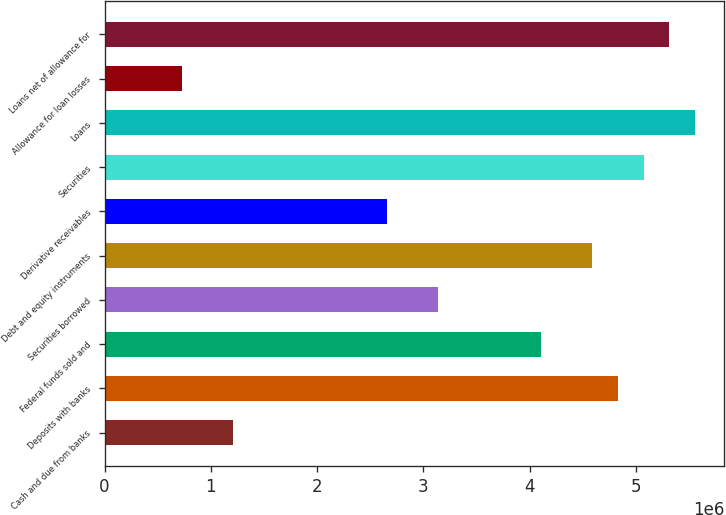<chart> <loc_0><loc_0><loc_500><loc_500><bar_chart><fcel>Cash and due from banks<fcel>Deposits with banks<fcel>Federal funds sold and<fcel>Securities borrowed<fcel>Debt and equity instruments<fcel>Derivative receivables<fcel>Securities<fcel>Loans<fcel>Allowance for loan losses<fcel>Loans net of allowance for<nl><fcel>1.20865e+06<fcel>4.82976e+06<fcel>4.10554e+06<fcel>3.13991e+06<fcel>4.58835e+06<fcel>2.6571e+06<fcel>5.07117e+06<fcel>5.55398e+06<fcel>725839<fcel>5.31257e+06<nl></chart> 